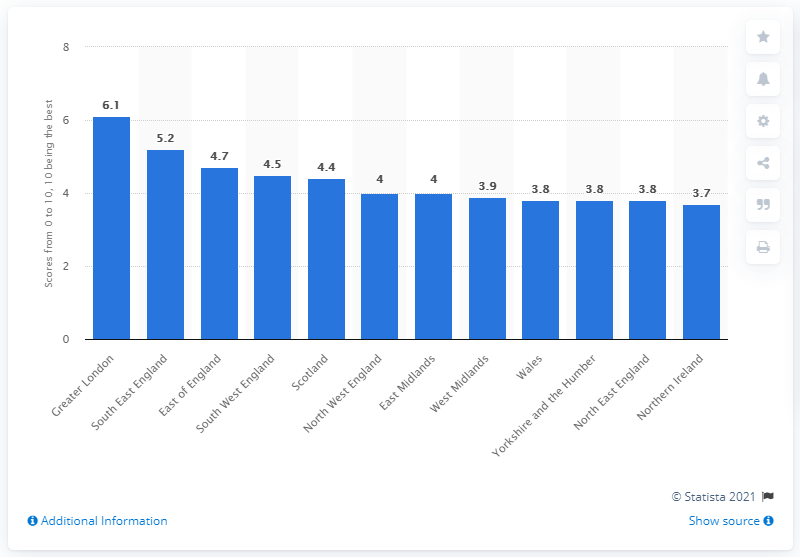Point out several critical features in this image. In 2018, Northern Ireland had the lowest income rating among all the regions in the country. The region of Greater London had the highest income rating in 2018. 